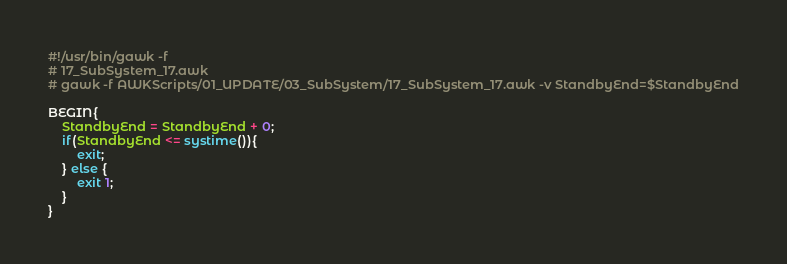Convert code to text. <code><loc_0><loc_0><loc_500><loc_500><_Awk_>#!/usr/bin/gawk -f
# 17_SubSystem_17.awk
# gawk -f AWKScripts/01_UPDATE/03_SubSystem/17_SubSystem_17.awk -v StandbyEnd=$StandbyEnd

BEGIN{
	StandbyEnd = StandbyEnd + 0;
	if(StandbyEnd <= systime()){
		exit;
	} else {
		exit 1;
	}
}

</code> 